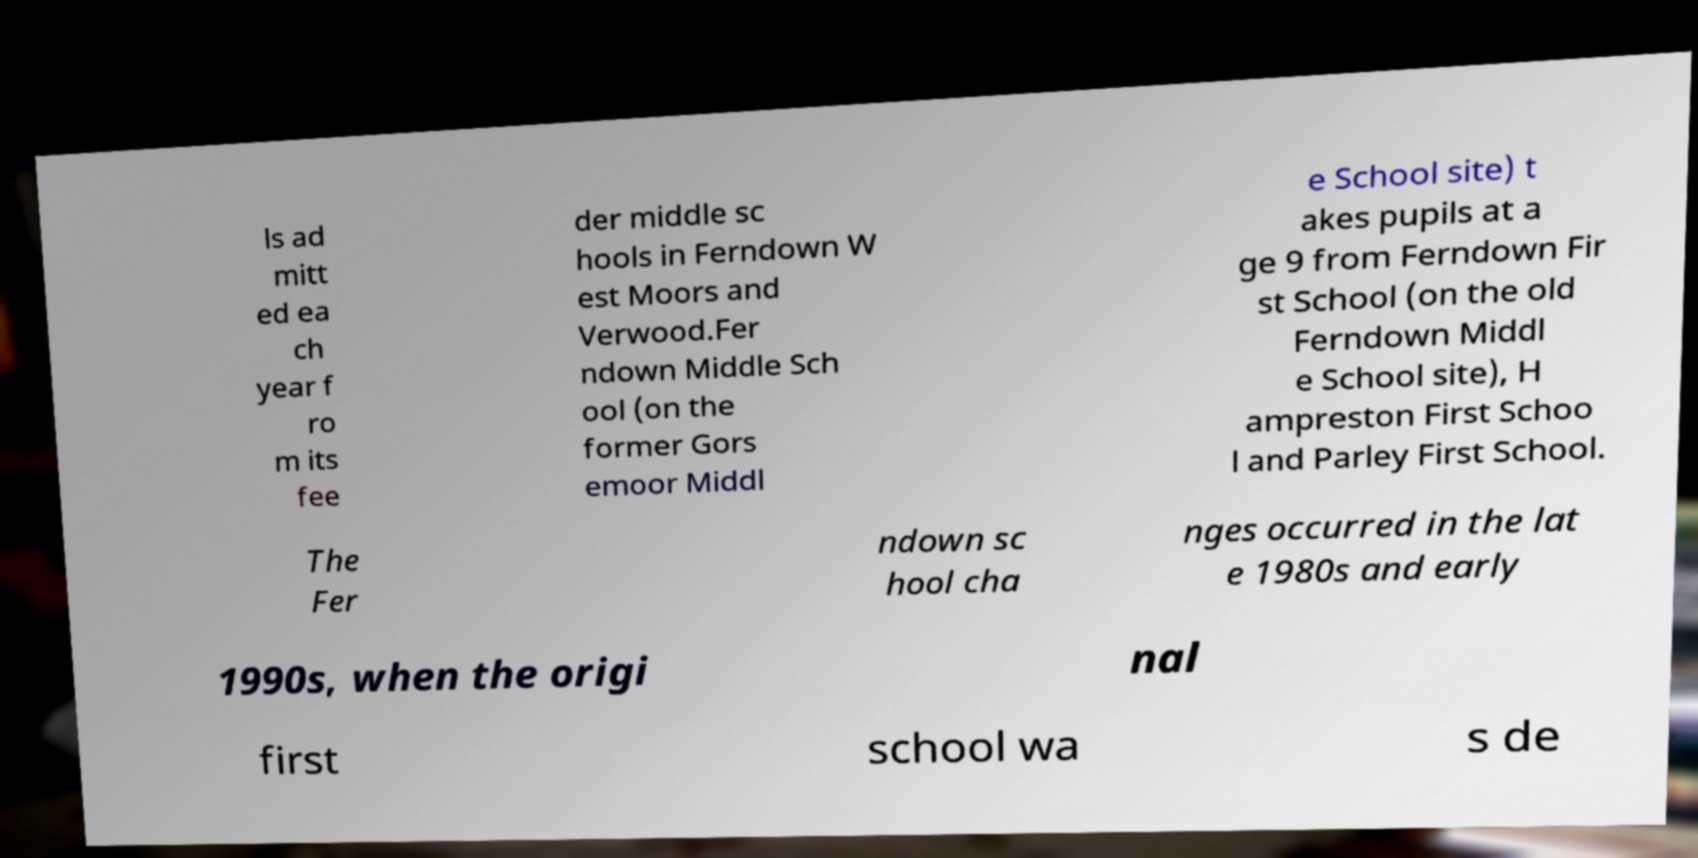I need the written content from this picture converted into text. Can you do that? ls ad mitt ed ea ch year f ro m its fee der middle sc hools in Ferndown W est Moors and Verwood.Fer ndown Middle Sch ool (on the former Gors emoor Middl e School site) t akes pupils at a ge 9 from Ferndown Fir st School (on the old Ferndown Middl e School site), H ampreston First Schoo l and Parley First School. The Fer ndown sc hool cha nges occurred in the lat e 1980s and early 1990s, when the origi nal first school wa s de 